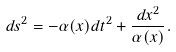<formula> <loc_0><loc_0><loc_500><loc_500>d s ^ { 2 } = - \alpha ( x ) d t ^ { 2 } + \frac { d x ^ { 2 } } { \alpha ( x ) } .</formula> 